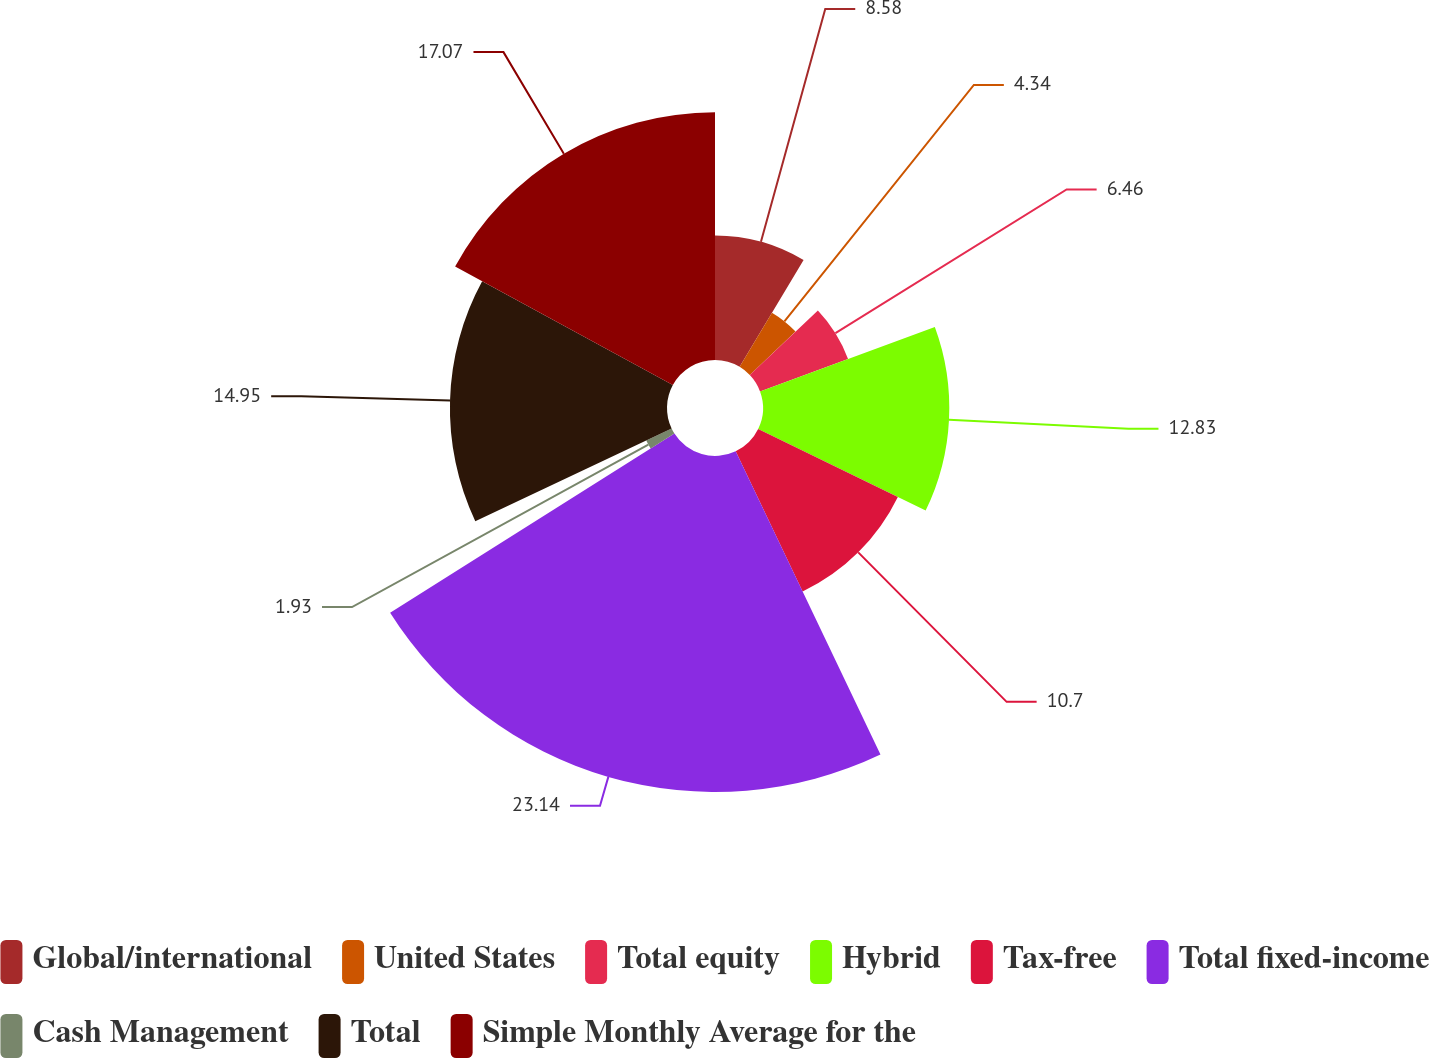Convert chart to OTSL. <chart><loc_0><loc_0><loc_500><loc_500><pie_chart><fcel>Global/international<fcel>United States<fcel>Total equity<fcel>Hybrid<fcel>Tax-free<fcel>Total fixed-income<fcel>Cash Management<fcel>Total<fcel>Simple Monthly Average for the<nl><fcel>8.58%<fcel>4.34%<fcel>6.46%<fcel>12.83%<fcel>10.7%<fcel>23.14%<fcel>1.93%<fcel>14.95%<fcel>17.07%<nl></chart> 